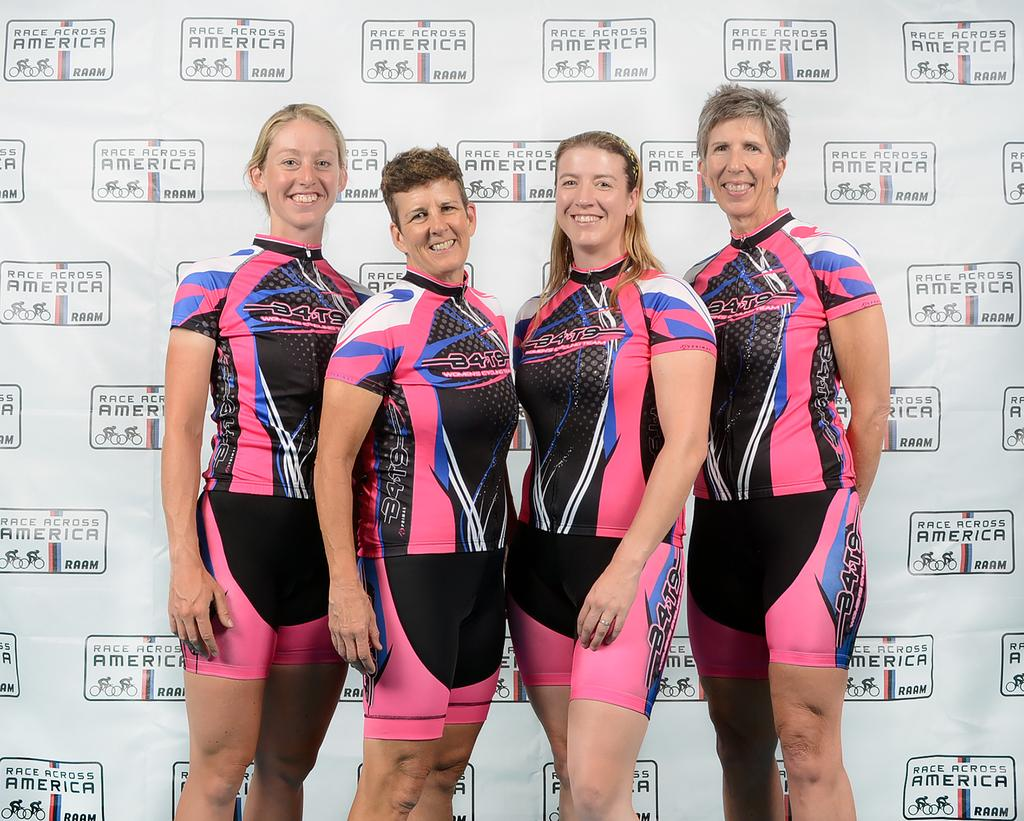<image>
Offer a succinct explanation of the picture presented. Four women wearing cycling team uniforms pose in a line. 